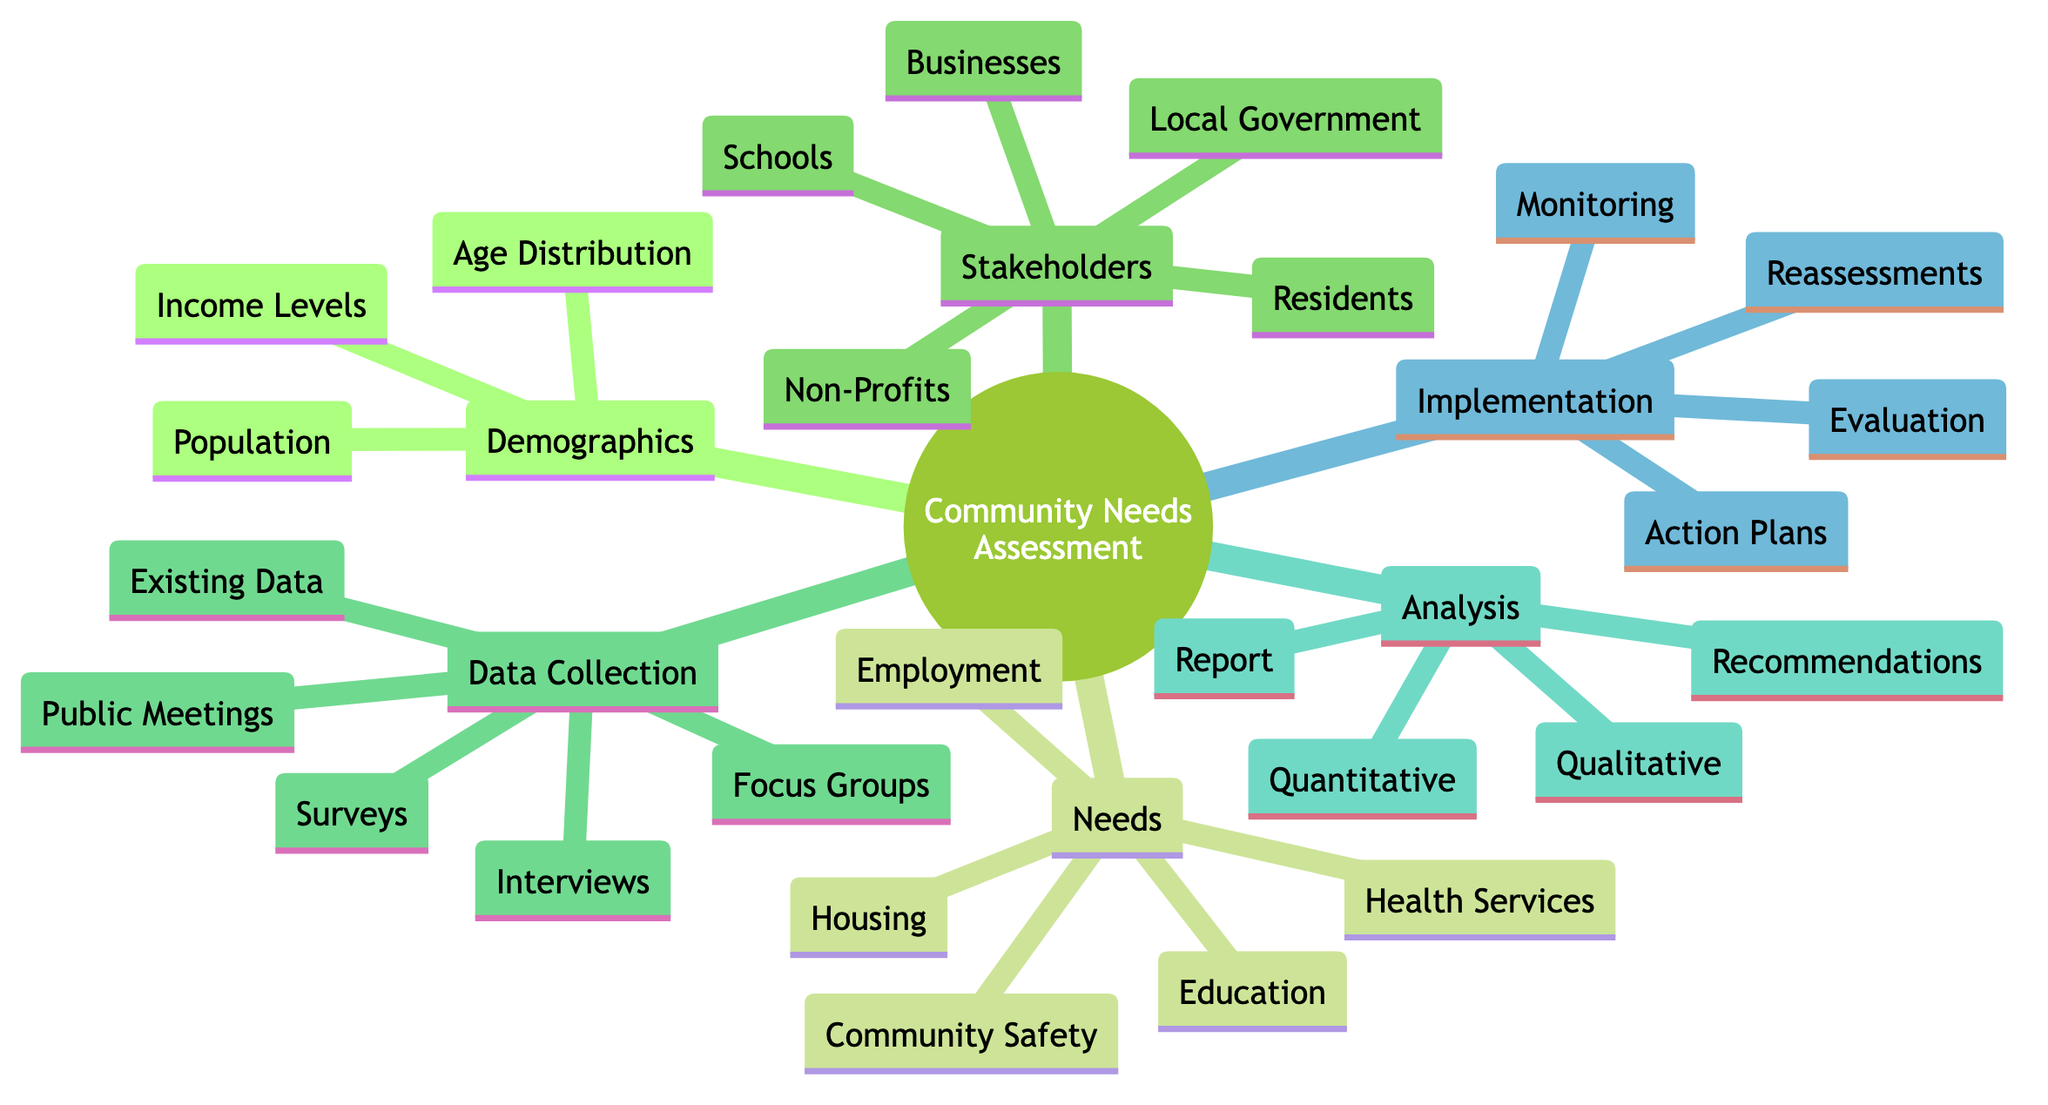What are the main categories in the needs assessment? The main categories in the needs assessment can be found as the first-level nodes branching from the root, which include Demographics, Needs, Stakeholders, Data Collection, Analysis, and Implementation.
Answer: Demographics, Needs, Stakeholders, Data Collection, Analysis, Implementation How many data collection methods are listed? To find the number of data collection methods, count the second-level nodes under the Data Collection category: Surveys, Focus Groups, Interviews, Public Meetings, and Existing Data, totaling five methods.
Answer: 5 What type of analysis is done for stakeholder feedback? The types of analysis can be identified by looking at the Analysis category, which includes Quantitative Analysis and Qualitative Analysis as well as Report Generation and Recommendations.
Answer: Quantitative, Qualitative Which group is involved in the assessment under Stakeholder Engagement? By examining the Stakeholder Engagement category, we can list the groups involved: Local Government, Non-Profit Organizations, Businesses, Residents, and Schools. The question asks for a group, any of these can be named.
Answer: Local Government How is the population described in the demographics? The demographics node elaborates on its main aspects, which are Population Size, Age Groups, and Socioeconomic Status for Income Levels. These are descriptors of the population.
Answer: Population Size, Age Groups, Socioeconomic Status What is one method of feedback analysis mentioned? Referencing the Feedback Analysis category reveals that it includes Quantitative Analysis, Qualitative Analysis, Report Generation, and Recommendations. Any one method from this list would suffice for the answer.
Answer: Quantitative Analysis What is the first step in the implementation process? This can be found by looking at the Implementation category, where the first listed action is Action Plans. Therefore, this is the first step in the process.
Answer: Action Plans How many stakeholders were identified in the diagram? The Stakeholder Engagement section lists five groups: Local Government, Non-Profit Organizations, Businesses, Residents, and Schools. Count these to find the total number of stakeholders identified.
Answer: 5 What assessment occurs periodically in the implementation phase? Reviewing the Implementation category highlights Reassessments as the activity that occurs periodically. This indicates that periodic evaluations of the community's needs are conducted.
Answer: Reassessments 